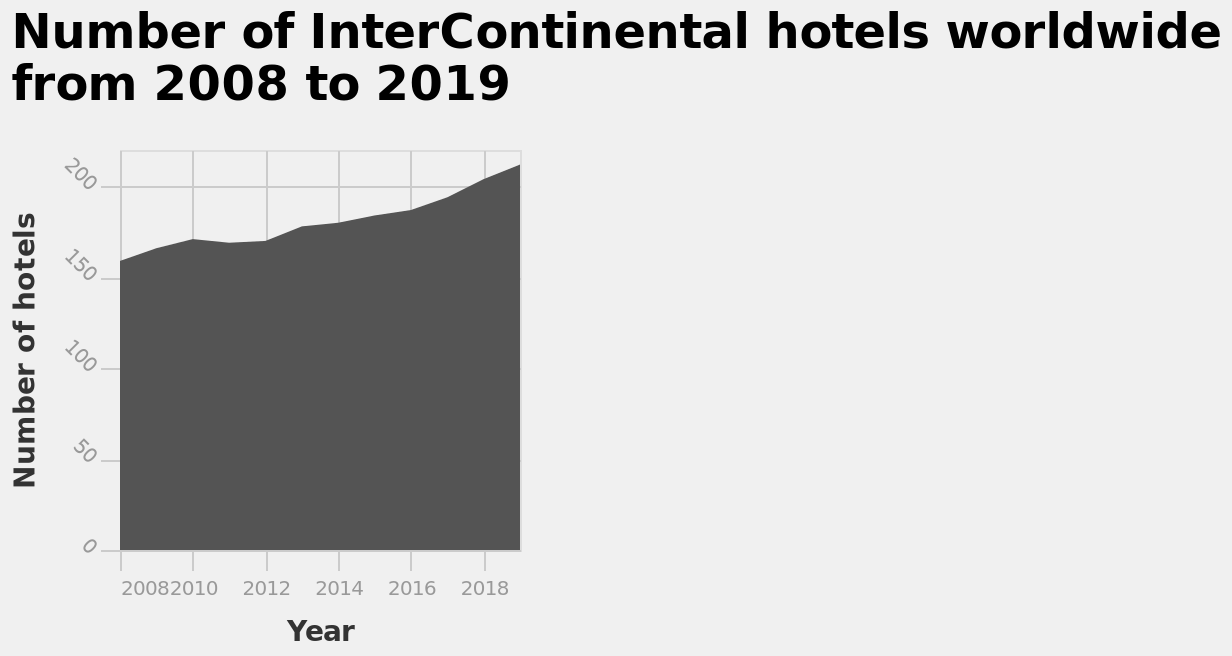<image>
What is plotted on the x-axis of the diagram? The x-axis of the diagram plots the years from 2008 to 2018. Has there been any change in the number of intercontinental hotels in recent years?  Yes, the number of intercontinental hotels has gradually increased over the past few years. 